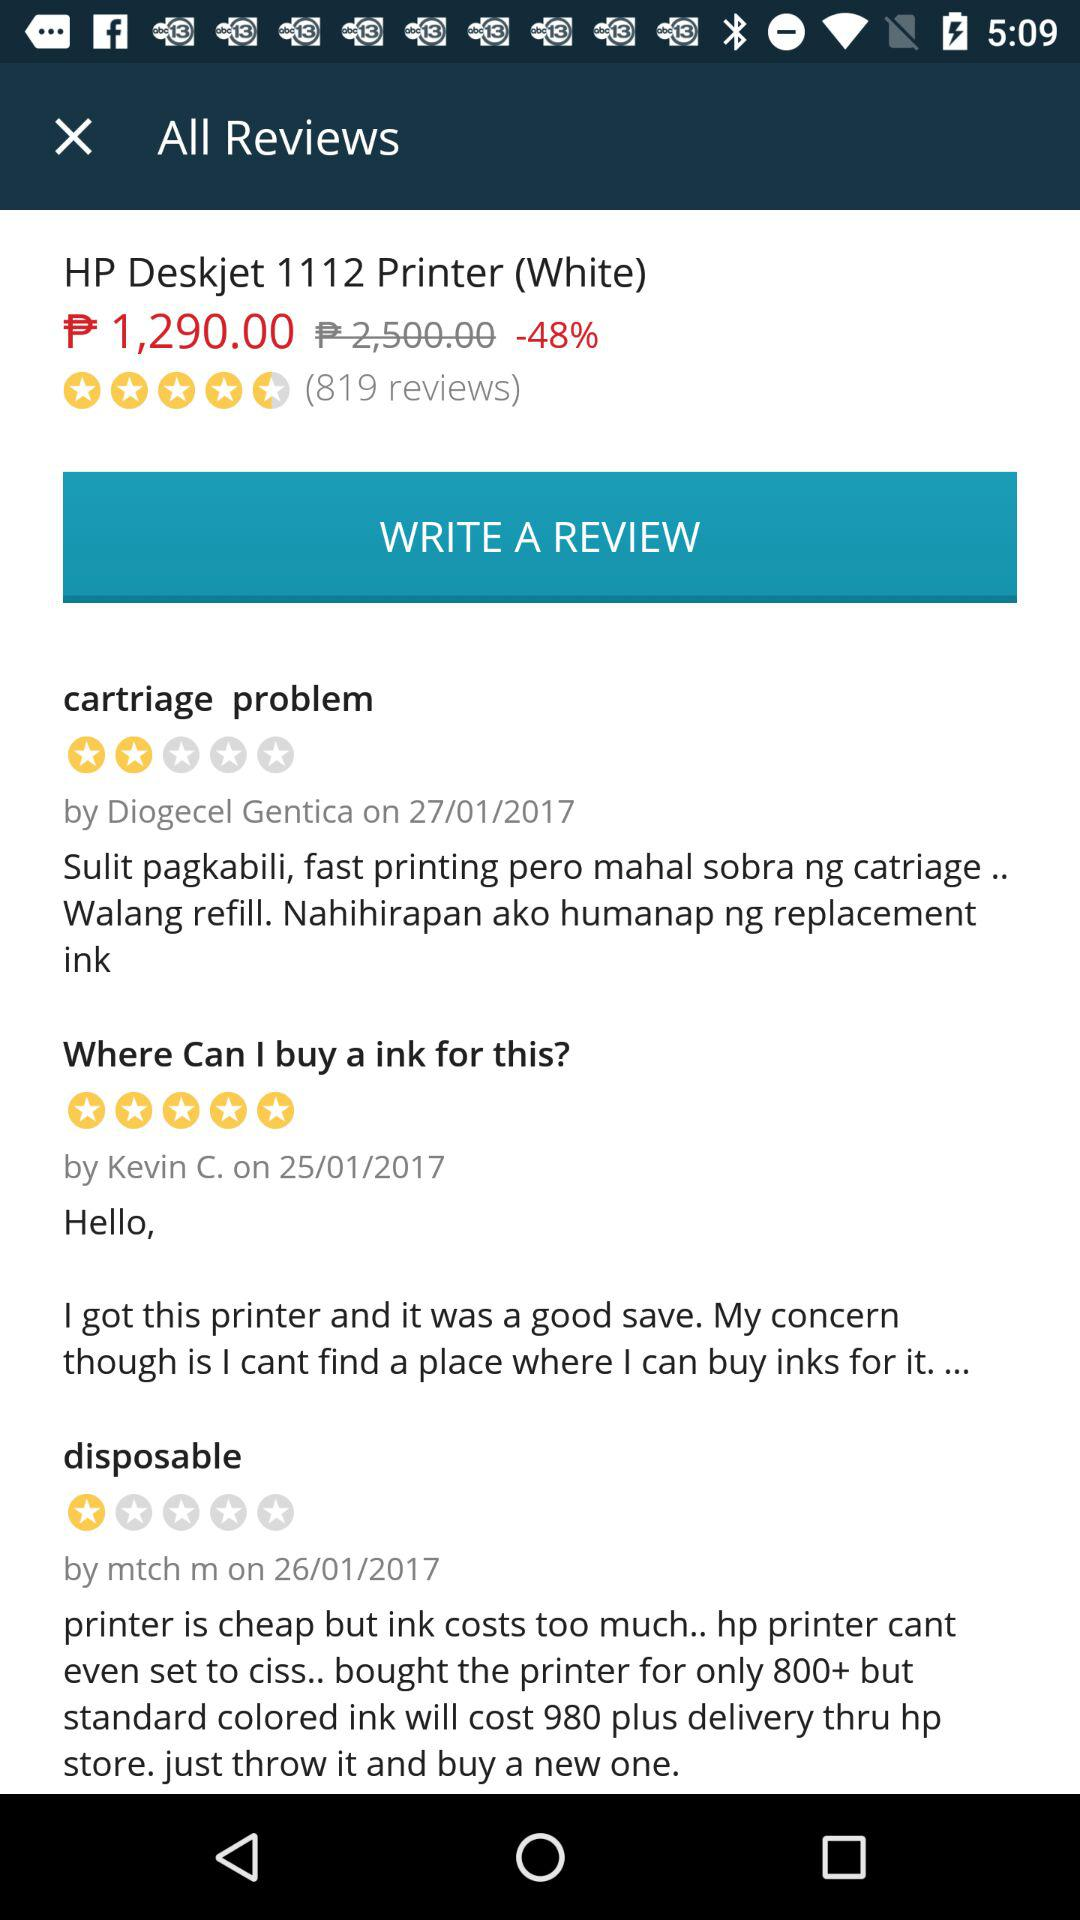How many ratings were given by Kevin C? Kevin C gave 5 stars. 